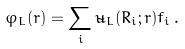Convert formula to latex. <formula><loc_0><loc_0><loc_500><loc_500>\varphi _ { L } ( r ) = \sum _ { i } \tilde { u } _ { L } ( R _ { i } ; r ) f _ { i } \, .</formula> 